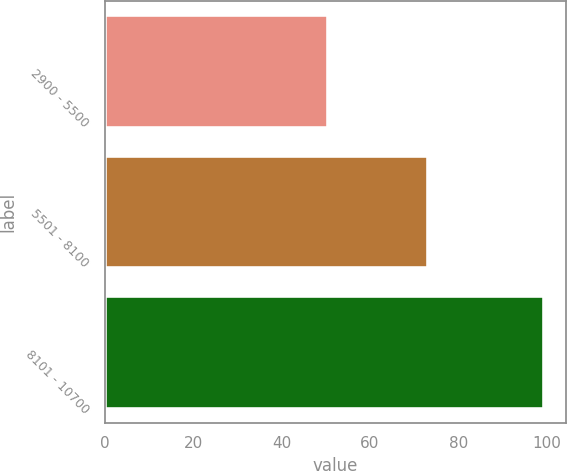Convert chart to OTSL. <chart><loc_0><loc_0><loc_500><loc_500><bar_chart><fcel>2900 - 5500<fcel>5501 - 8100<fcel>8101 - 10700<nl><fcel>50.66<fcel>73.18<fcel>99.41<nl></chart> 